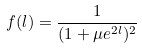Convert formula to latex. <formula><loc_0><loc_0><loc_500><loc_500>f ( l ) = \frac { 1 } { ( 1 + \mu e ^ { 2 l } ) ^ { 2 } }</formula> 